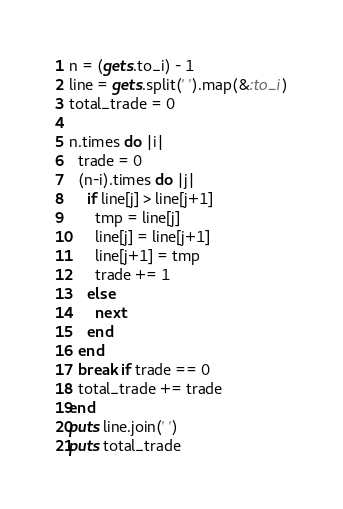Convert code to text. <code><loc_0><loc_0><loc_500><loc_500><_Ruby_>n = (gets.to_i) - 1
line = gets.split(' ').map(&:to_i)
total_trade = 0

n.times do |i|
  trade = 0
  (n-i).times do |j|
    if line[j] > line[j+1]
      tmp = line[j]
      line[j] = line[j+1]
      line[j+1] = tmp
      trade += 1
    else
      next
    end
  end
  break if trade == 0
  total_trade += trade
end
puts line.join(' ')
puts total_trade
</code> 